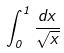<formula> <loc_0><loc_0><loc_500><loc_500>\int _ { 0 } ^ { 1 } \frac { d x } { \sqrt { x } }</formula> 